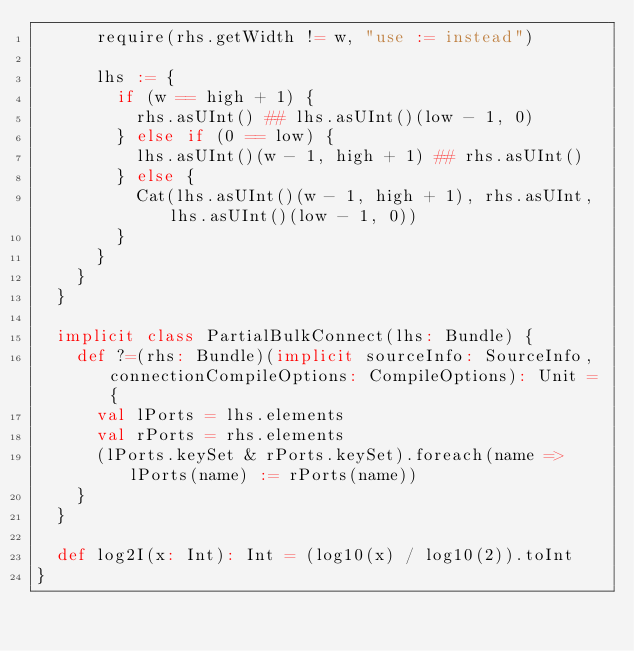<code> <loc_0><loc_0><loc_500><loc_500><_Scala_>      require(rhs.getWidth != w, "use := instead")

      lhs := {
        if (w == high + 1) {
          rhs.asUInt() ## lhs.asUInt()(low - 1, 0)
        } else if (0 == low) {
          lhs.asUInt()(w - 1, high + 1) ## rhs.asUInt()
        } else {
          Cat(lhs.asUInt()(w - 1, high + 1), rhs.asUInt, lhs.asUInt()(low - 1, 0))
        }
      }
    }
  }

  implicit class PartialBulkConnect(lhs: Bundle) {
    def ?=(rhs: Bundle)(implicit sourceInfo: SourceInfo, connectionCompileOptions: CompileOptions): Unit = {
      val lPorts = lhs.elements
      val rPorts = rhs.elements
      (lPorts.keySet & rPorts.keySet).foreach(name => lPorts(name) := rPorts(name))
    }
  }

  def log2I(x: Int): Int = (log10(x) / log10(2)).toInt
}
</code> 